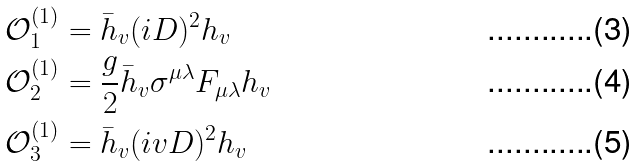<formula> <loc_0><loc_0><loc_500><loc_500>\mathcal { O } ^ { ( 1 ) } _ { 1 } & = \bar { h } _ { v } ( i D ) ^ { 2 } h _ { v } \\ \mathcal { O } ^ { ( 1 ) } _ { 2 } & = \frac { g } { 2 } \bar { h } _ { v } \sigma ^ { \mu \lambda } F _ { \mu \lambda } h _ { v } \\ \mathcal { O } ^ { ( 1 ) } _ { 3 } & = \bar { h } _ { v } ( i v D ) ^ { 2 } h _ { v }</formula> 